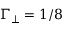Convert formula to latex. <formula><loc_0><loc_0><loc_500><loc_500>\Gamma _ { \perp } = 1 / 8</formula> 